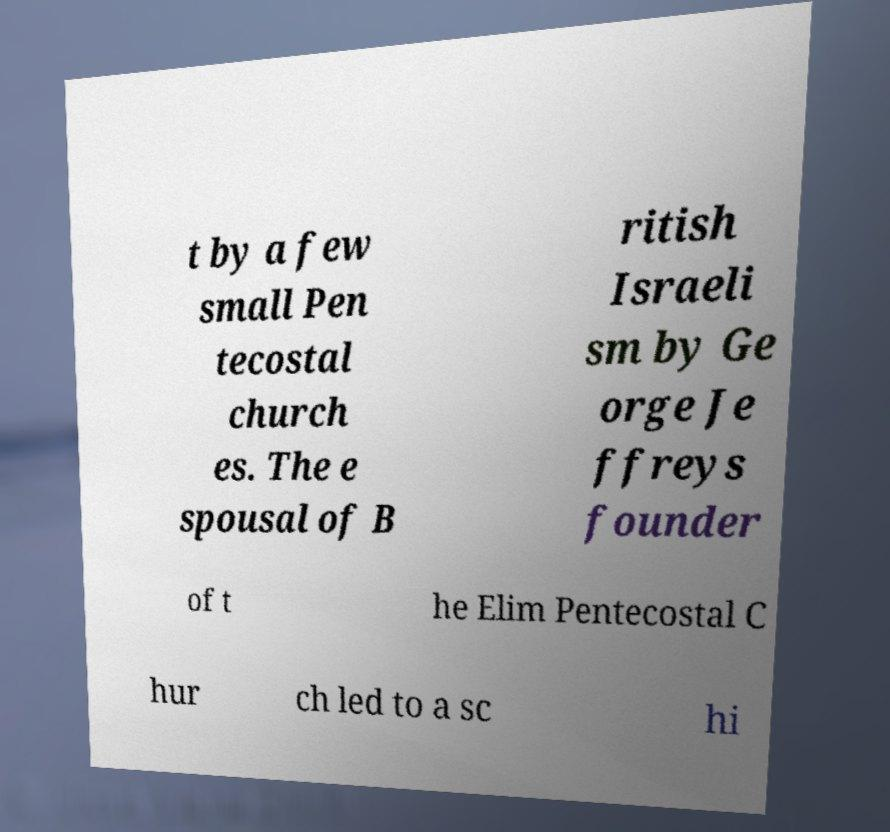Can you accurately transcribe the text from the provided image for me? t by a few small Pen tecostal church es. The e spousal of B ritish Israeli sm by Ge orge Je ffreys founder of t he Elim Pentecostal C hur ch led to a sc hi 